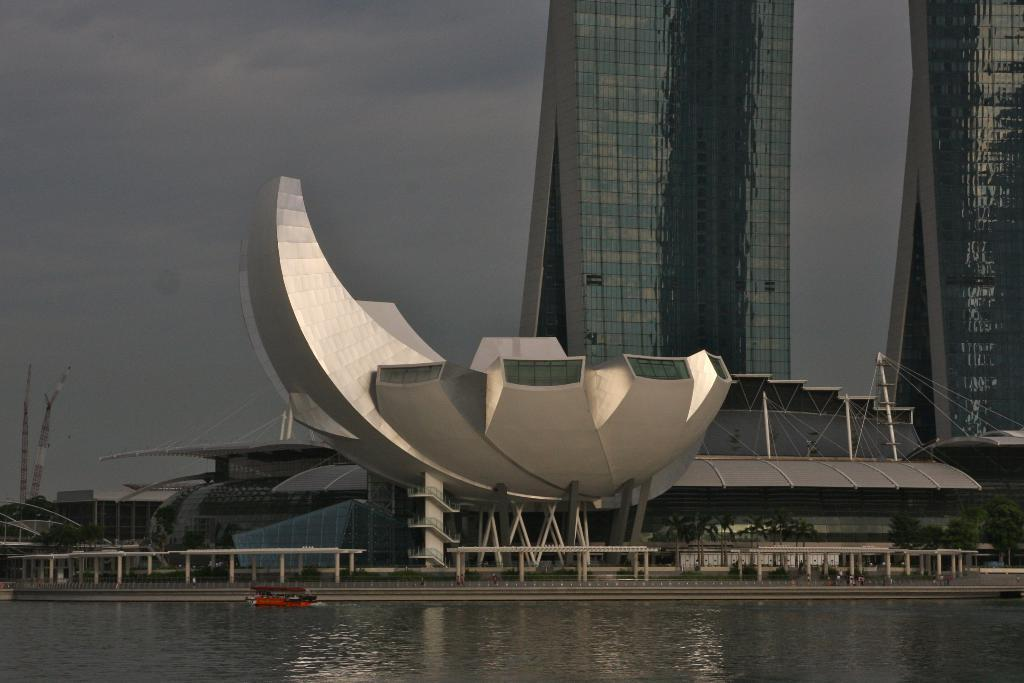What type of natural feature can be seen in the image? There is a river in the image. What is floating on the water in the image? There is a red color boat floating on the water. What type of structures can be seen in the image? There are buildings visible in the image. What is visible in the background of the image? The sky is visible in the background of the image. What can be observed in the sky? There are clouds in the sky. What type of vegetable is being hammered in the image? There is no vegetable or hammer present in the image. What type of friction is being generated by the boat in the image? The boat is floating on the water, so there is no friction being generated by the boat in the image. 